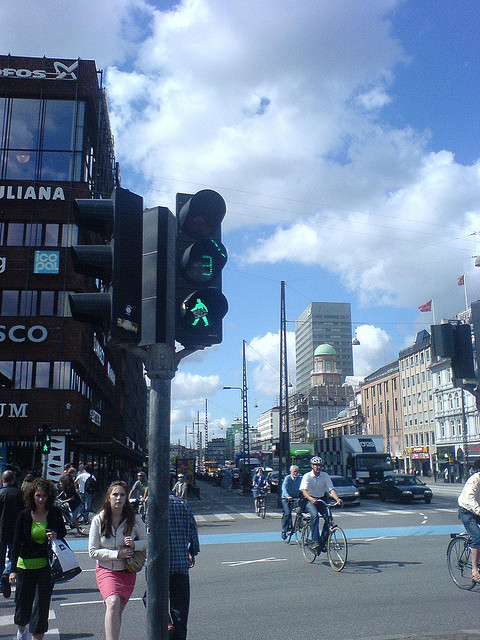Identify the text contained in this image. ULIANA SCO JM POL FOS ico 